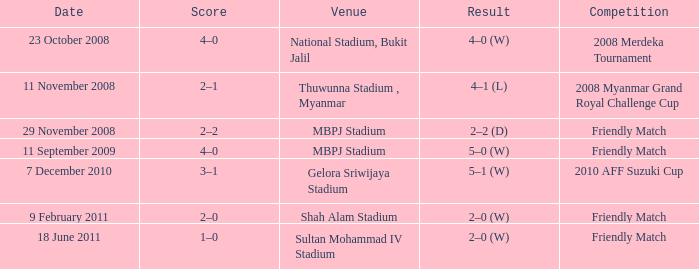What Competition had a Score of 2–0? Friendly Match. Can you parse all the data within this table? {'header': ['Date', 'Score', 'Venue', 'Result', 'Competition'], 'rows': [['23 October 2008', '4–0', 'National Stadium, Bukit Jalil', '4–0 (W)', '2008 Merdeka Tournament'], ['11 November 2008', '2–1', 'Thuwunna Stadium , Myanmar', '4–1 (L)', '2008 Myanmar Grand Royal Challenge Cup'], ['29 November 2008', '2–2', 'MBPJ Stadium', '2–2 (D)', 'Friendly Match'], ['11 September 2009', '4–0', 'MBPJ Stadium', '5–0 (W)', 'Friendly Match'], ['7 December 2010', '3–1', 'Gelora Sriwijaya Stadium', '5–1 (W)', '2010 AFF Suzuki Cup'], ['9 February 2011', '2–0', 'Shah Alam Stadium', '2–0 (W)', 'Friendly Match'], ['18 June 2011', '1–0', 'Sultan Mohammad IV Stadium', '2–0 (W)', 'Friendly Match']]} 